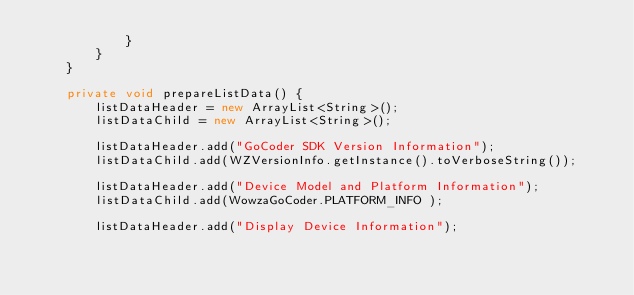Convert code to text. <code><loc_0><loc_0><loc_500><loc_500><_Java_>            }
        }
    }

    private void prepareListData() {
        listDataHeader = new ArrayList<String>();
        listDataChild = new ArrayList<String>();

        listDataHeader.add("GoCoder SDK Version Information");
        listDataChild.add(WZVersionInfo.getInstance().toVerboseString());

        listDataHeader.add("Device Model and Platform Information");
        listDataChild.add(WowzaGoCoder.PLATFORM_INFO );

        listDataHeader.add("Display Device Information");</code> 